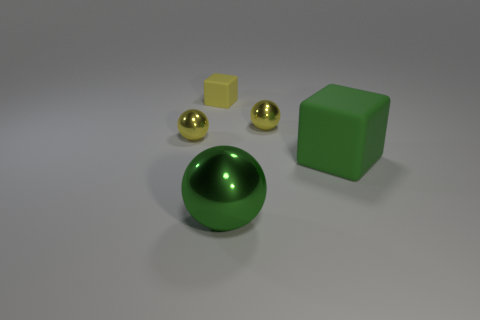Add 5 small yellow rubber objects. How many objects exist? 10 Subtract all cubes. How many objects are left? 3 Subtract 0 brown balls. How many objects are left? 5 Subtract all tiny green metal spheres. Subtract all big green balls. How many objects are left? 4 Add 1 green metal things. How many green metal things are left? 2 Add 1 small yellow cubes. How many small yellow cubes exist? 2 